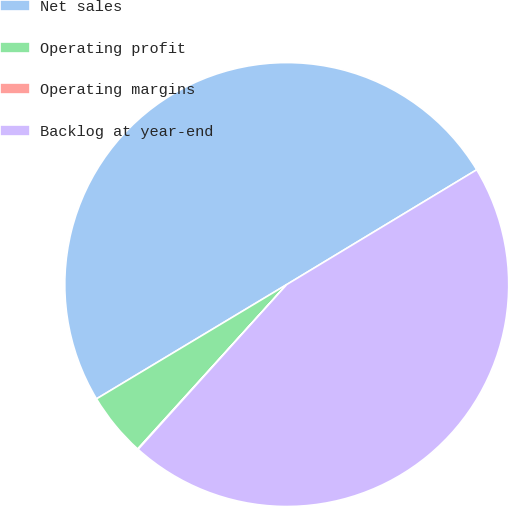Convert chart to OTSL. <chart><loc_0><loc_0><loc_500><loc_500><pie_chart><fcel>Net sales<fcel>Operating profit<fcel>Operating margins<fcel>Backlog at year-end<nl><fcel>49.96%<fcel>4.67%<fcel>0.04%<fcel>45.33%<nl></chart> 